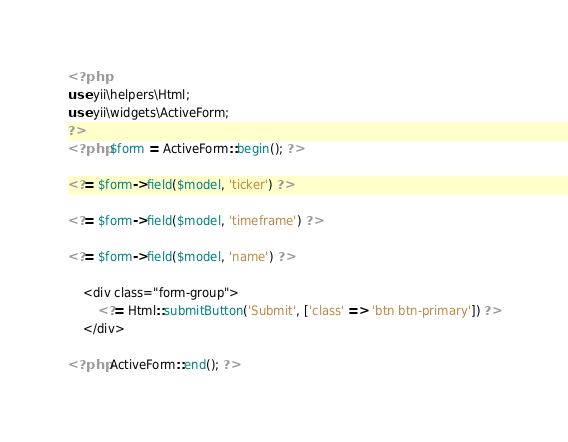Convert code to text. <code><loc_0><loc_0><loc_500><loc_500><_PHP_><?php
use yii\helpers\Html;
use yii\widgets\ActiveForm;
?>
<?php $form = ActiveForm::begin(); ?>

<?= $form->field($model, 'ticker') ?>

<?= $form->field($model, 'timeframe') ?>

<?= $form->field($model, 'name') ?>

    <div class="form-group">
        <?= Html::submitButton('Submit', ['class' => 'btn btn-primary']) ?>
    </div>

<?php ActiveForm::end(); ?></code> 